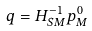Convert formula to latex. <formula><loc_0><loc_0><loc_500><loc_500>q = { H _ { S M } ^ { - 1 } } { { p } _ { M } ^ { 0 } }</formula> 